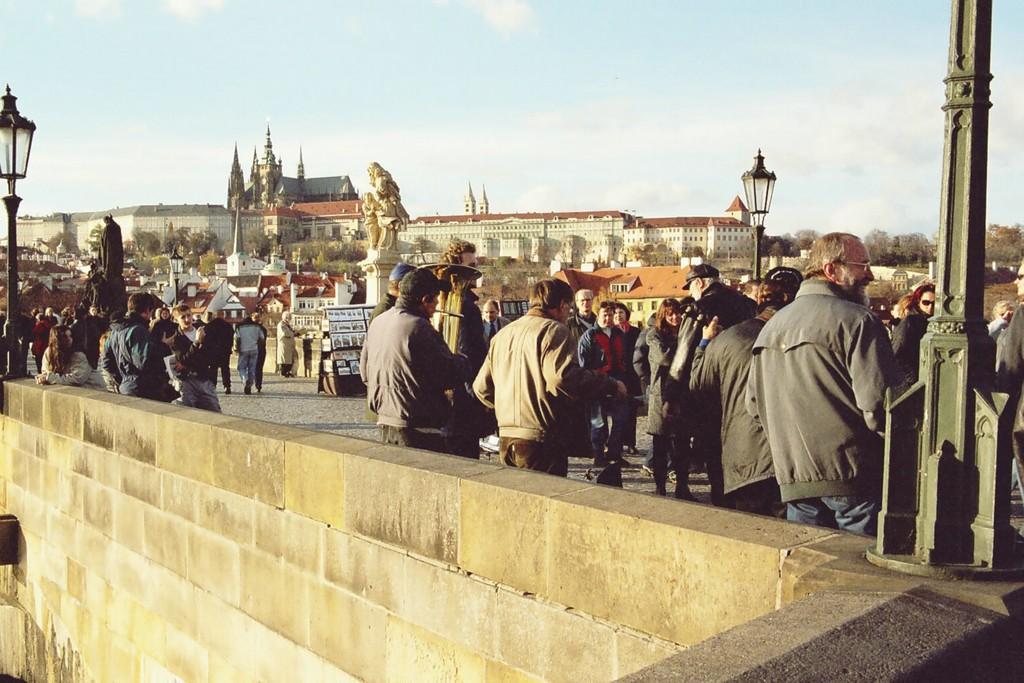Describe this image in one or two sentences. In front of the image there is a wall. There are light poles. There are books on the rack. There are people standing on the road. There are statues. In the background of the image there are buildings, trees. At the top of the image there are clouds in the sky. 